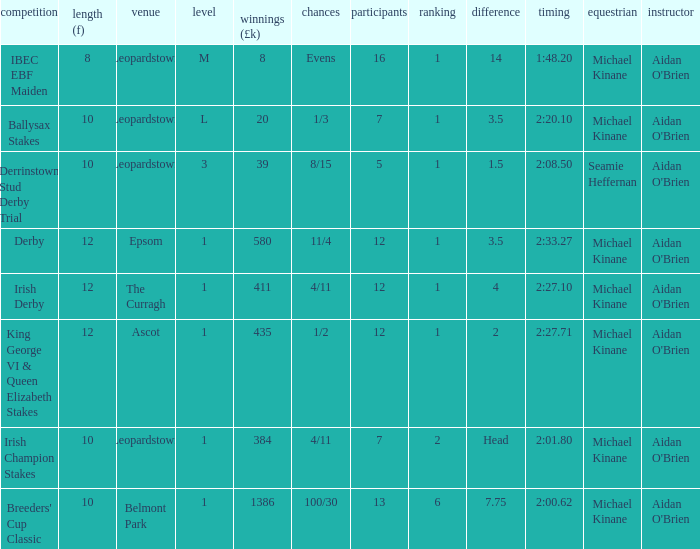Which Race has a Runners of 7 and Odds of 1/3? Ballysax Stakes. 